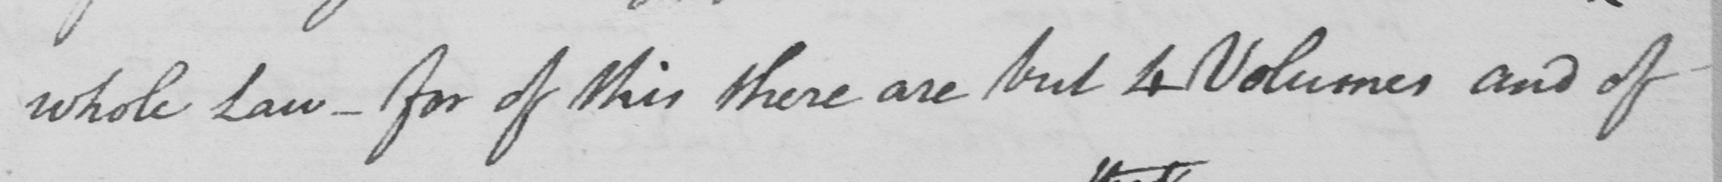What does this handwritten line say? whole Law  _  for of this there are but 4 Volumes and of 